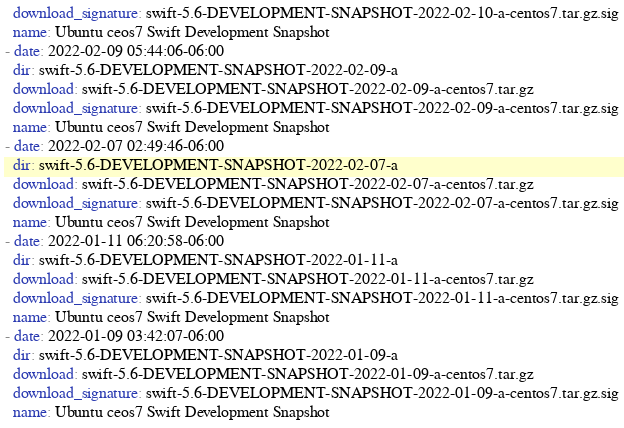<code> <loc_0><loc_0><loc_500><loc_500><_YAML_>  download_signature: swift-5.6-DEVELOPMENT-SNAPSHOT-2022-02-10-a-centos7.tar.gz.sig
  name: Ubuntu ceos7 Swift Development Snapshot
- date: 2022-02-09 05:44:06-06:00
  dir: swift-5.6-DEVELOPMENT-SNAPSHOT-2022-02-09-a
  download: swift-5.6-DEVELOPMENT-SNAPSHOT-2022-02-09-a-centos7.tar.gz
  download_signature: swift-5.6-DEVELOPMENT-SNAPSHOT-2022-02-09-a-centos7.tar.gz.sig
  name: Ubuntu ceos7 Swift Development Snapshot
- date: 2022-02-07 02:49:46-06:00
  dir: swift-5.6-DEVELOPMENT-SNAPSHOT-2022-02-07-a
  download: swift-5.6-DEVELOPMENT-SNAPSHOT-2022-02-07-a-centos7.tar.gz
  download_signature: swift-5.6-DEVELOPMENT-SNAPSHOT-2022-02-07-a-centos7.tar.gz.sig
  name: Ubuntu ceos7 Swift Development Snapshot
- date: 2022-01-11 06:20:58-06:00
  dir: swift-5.6-DEVELOPMENT-SNAPSHOT-2022-01-11-a
  download: swift-5.6-DEVELOPMENT-SNAPSHOT-2022-01-11-a-centos7.tar.gz
  download_signature: swift-5.6-DEVELOPMENT-SNAPSHOT-2022-01-11-a-centos7.tar.gz.sig
  name: Ubuntu ceos7 Swift Development Snapshot
- date: 2022-01-09 03:42:07-06:00
  dir: swift-5.6-DEVELOPMENT-SNAPSHOT-2022-01-09-a
  download: swift-5.6-DEVELOPMENT-SNAPSHOT-2022-01-09-a-centos7.tar.gz
  download_signature: swift-5.6-DEVELOPMENT-SNAPSHOT-2022-01-09-a-centos7.tar.gz.sig
  name: Ubuntu ceos7 Swift Development Snapshot
</code> 